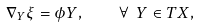<formula> <loc_0><loc_0><loc_500><loc_500>\nabla _ { Y } \xi = \phi Y , \quad \forall \ Y \in T X ,</formula> 